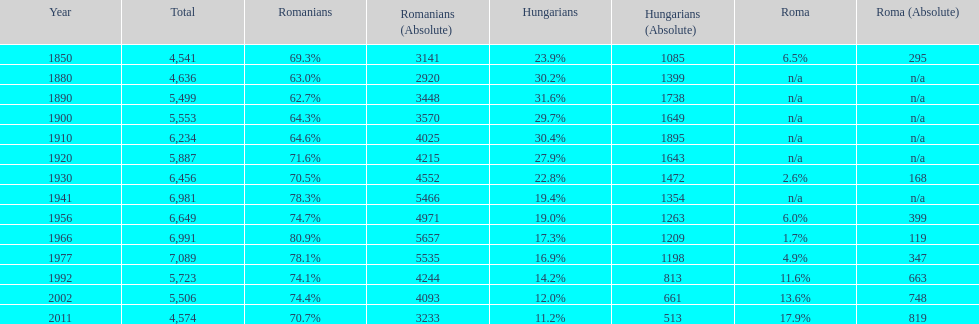Can you parse all the data within this table? {'header': ['Year', 'Total', 'Romanians', 'Romanians (Absolute)', 'Hungarians', 'Hungarians (Absolute)', 'Roma', 'Roma (Absolute)'], 'rows': [['1850', '4,541', '69.3%', '3141', '23.9%', '1085', '6.5%', '295'], ['1880', '4,636', '63.0%', '2920', '30.2%', '1399', 'n/a', 'n/a'], ['1890', '5,499', '62.7%', '3448', '31.6%', '1738', 'n/a', 'n/a'], ['1900', '5,553', '64.3%', '3570', '29.7%', '1649', 'n/a', 'n/a'], ['1910', '6,234', '64.6%', '4025', '30.4%', '1895', 'n/a', 'n/a'], ['1920', '5,887', '71.6%', '4215', '27.9%', '1643', 'n/a', 'n/a'], ['1930', '6,456', '70.5%', '4552', '22.8%', '1472', '2.6%', '168'], ['1941', '6,981', '78.3%', '5466', '19.4%', '1354', 'n/a', 'n/a'], ['1956', '6,649', '74.7%', '4971', '19.0%', '1263', '6.0%', '399'], ['1966', '6,991', '80.9%', '5657', '17.3%', '1209', '1.7%', '119'], ['1977', '7,089', '78.1%', '5535', '16.9%', '1198', '4.9%', '347'], ['1992', '5,723', '74.1%', '4244', '14.2%', '813', '11.6%', '663'], ['2002', '5,506', '74.4%', '4093', '12.0%', '661', '13.6%', '748'], ['2011', '4,574', '70.7%', '3233', '11.2%', '513', '17.9%', '819']]} Which year is previous to the year that had 74.1% in romanian population? 1977. 